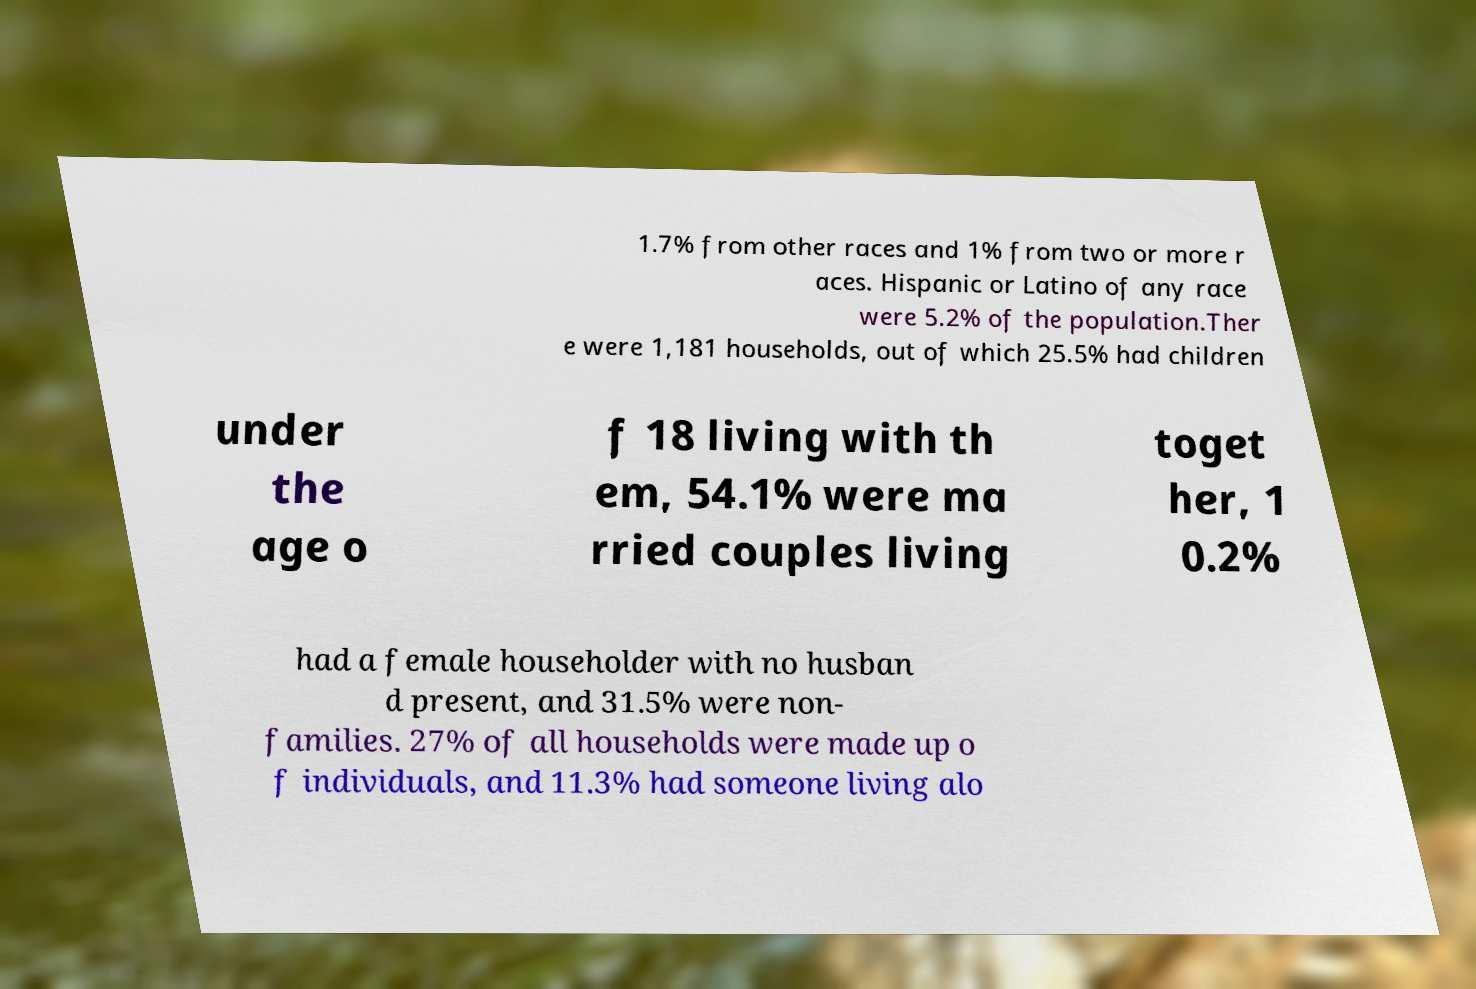Could you extract and type out the text from this image? 1.7% from other races and 1% from two or more r aces. Hispanic or Latino of any race were 5.2% of the population.Ther e were 1,181 households, out of which 25.5% had children under the age o f 18 living with th em, 54.1% were ma rried couples living toget her, 1 0.2% had a female householder with no husban d present, and 31.5% were non- families. 27% of all households were made up o f individuals, and 11.3% had someone living alo 